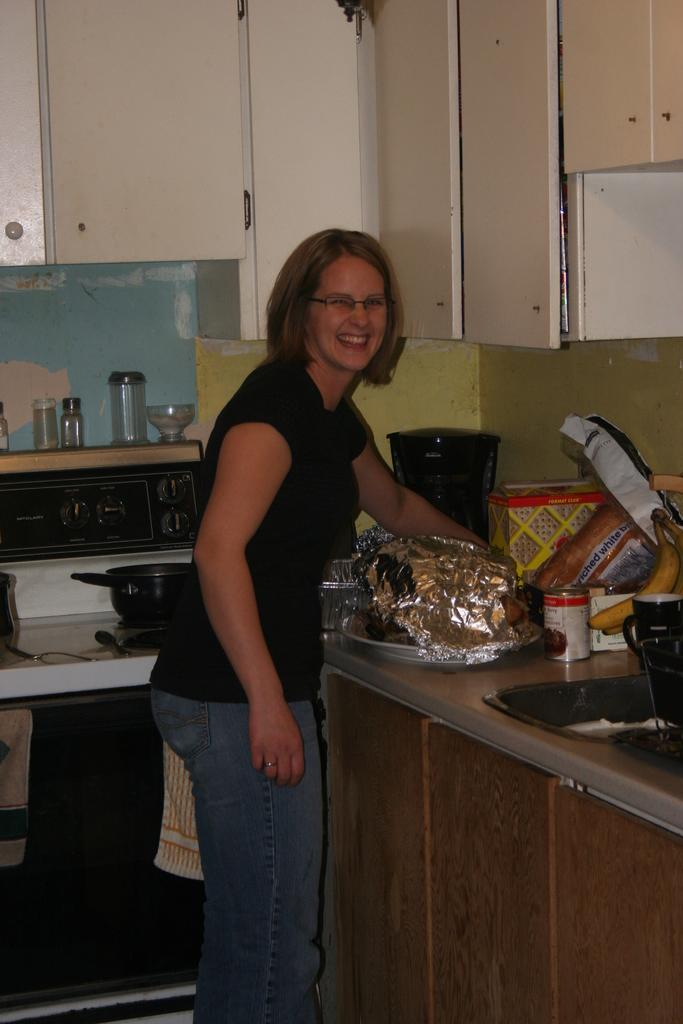<image>
Render a clear and concise summary of the photo. a smiling woman reaching for a loaf of WHITE BREAD in a kitchen 